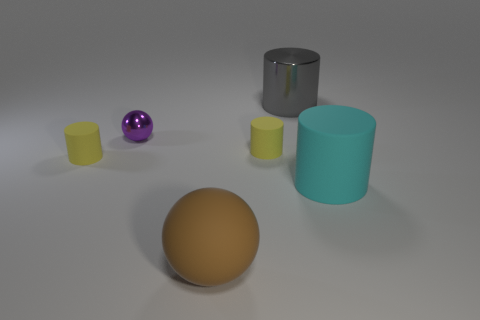Subtract all shiny cylinders. How many cylinders are left? 3 Subtract all gray cylinders. How many cylinders are left? 3 Add 1 big purple matte objects. How many objects exist? 7 Subtract all cylinders. How many objects are left? 2 Subtract 3 cylinders. How many cylinders are left? 1 Add 2 small yellow cylinders. How many small yellow cylinders are left? 4 Add 3 yellow metal things. How many yellow metal things exist? 3 Subtract 0 blue cylinders. How many objects are left? 6 Subtract all red balls. Subtract all blue blocks. How many balls are left? 2 Subtract all blue spheres. How many yellow cylinders are left? 2 